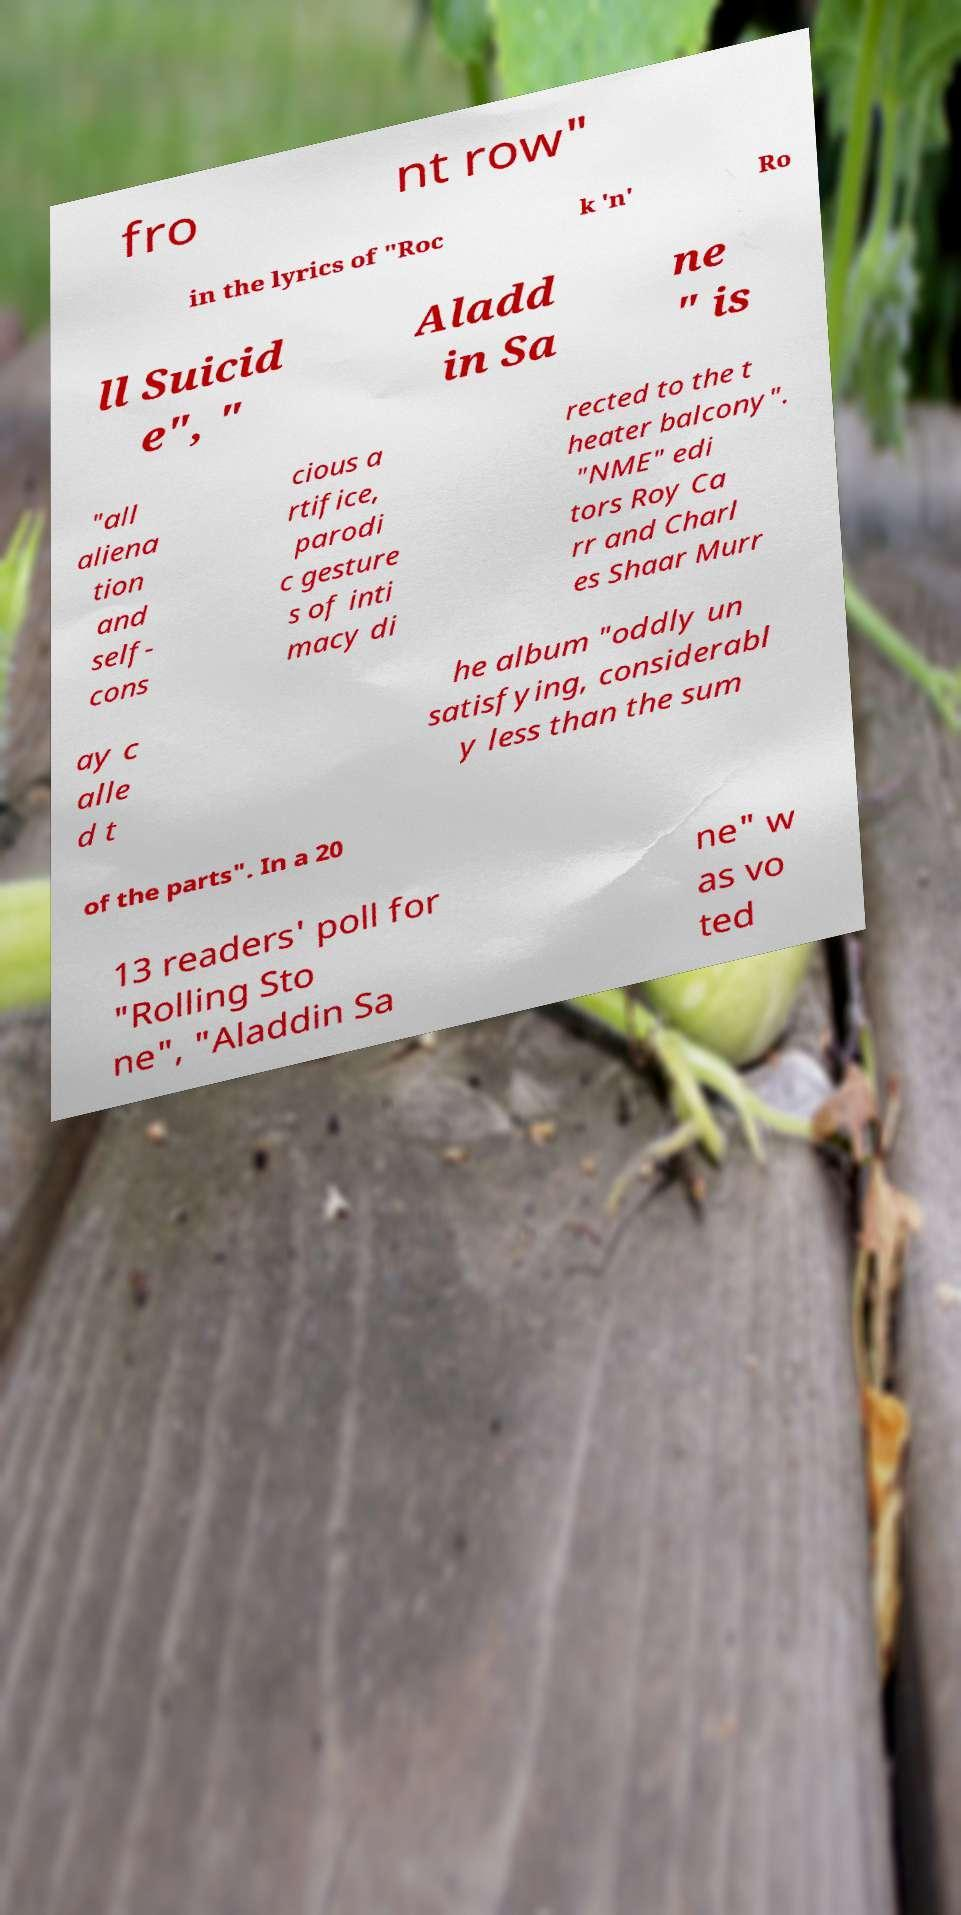What messages or text are displayed in this image? I need them in a readable, typed format. fro nt row" in the lyrics of "Roc k 'n' Ro ll Suicid e", " Aladd in Sa ne " is "all aliena tion and self- cons cious a rtifice, parodi c gesture s of inti macy di rected to the t heater balcony". "NME" edi tors Roy Ca rr and Charl es Shaar Murr ay c alle d t he album "oddly un satisfying, considerabl y less than the sum of the parts". In a 20 13 readers' poll for "Rolling Sto ne", "Aladdin Sa ne" w as vo ted 